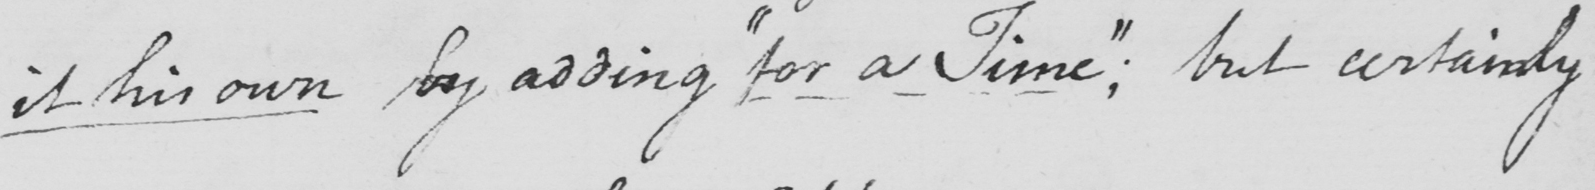What does this handwritten line say? it his own by adding  " for a Time "  ; but certainly 